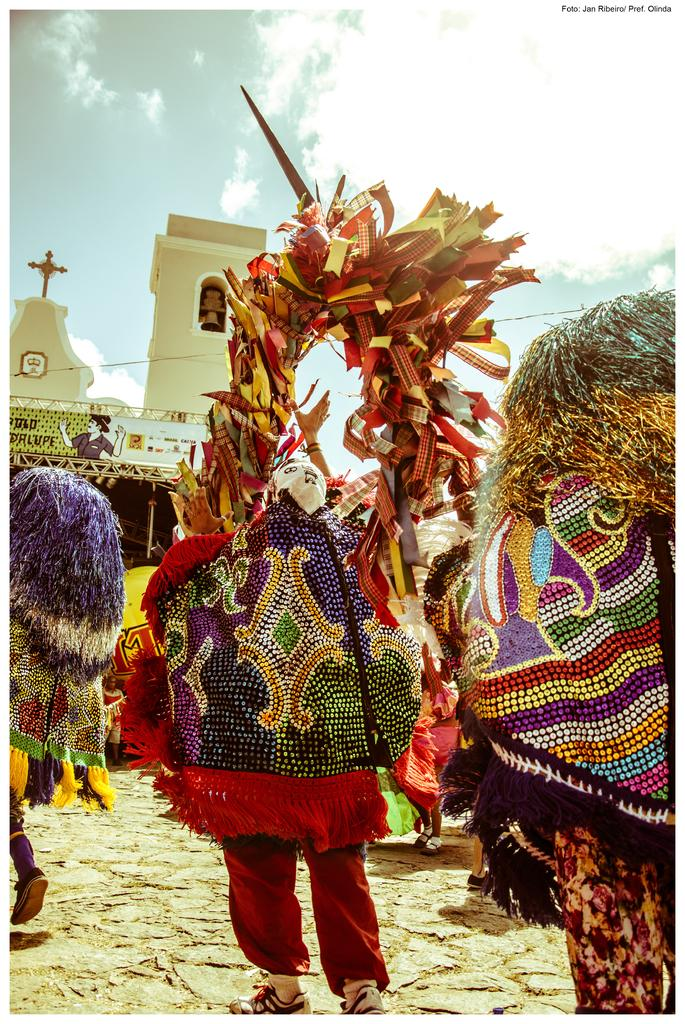How many people are in the image? There are three persons in the image. What are the persons wearing? The persons are wearing fancy dress. What are the persons holding in their hands? The persons are holding an object in their hands. What can be seen in the background of the image? There is a building in the background of the image. Are the three persons in the image sisters? There is no information in the image to determine if the three persons are sisters or not. What type of instrument is the person on the left playing in the image? There is no instrument present in the image, so it cannot be determined what type of instrument the person might be playing. 